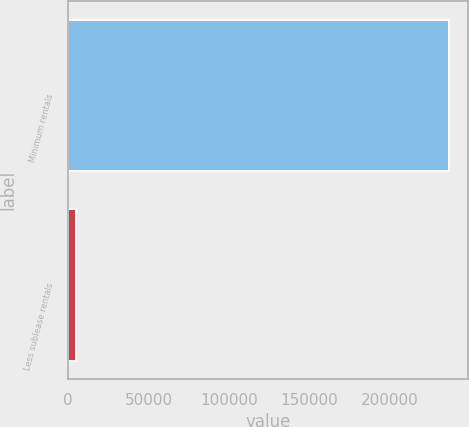Convert chart to OTSL. <chart><loc_0><loc_0><loc_500><loc_500><bar_chart><fcel>Minimum rentals<fcel>Less sublease rentals<nl><fcel>236965<fcel>4673<nl></chart> 